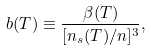Convert formula to latex. <formula><loc_0><loc_0><loc_500><loc_500>b ( T ) \equiv \frac { \beta ( T ) } { [ n _ { s } ( T ) / n ] ^ { 3 } } ,</formula> 